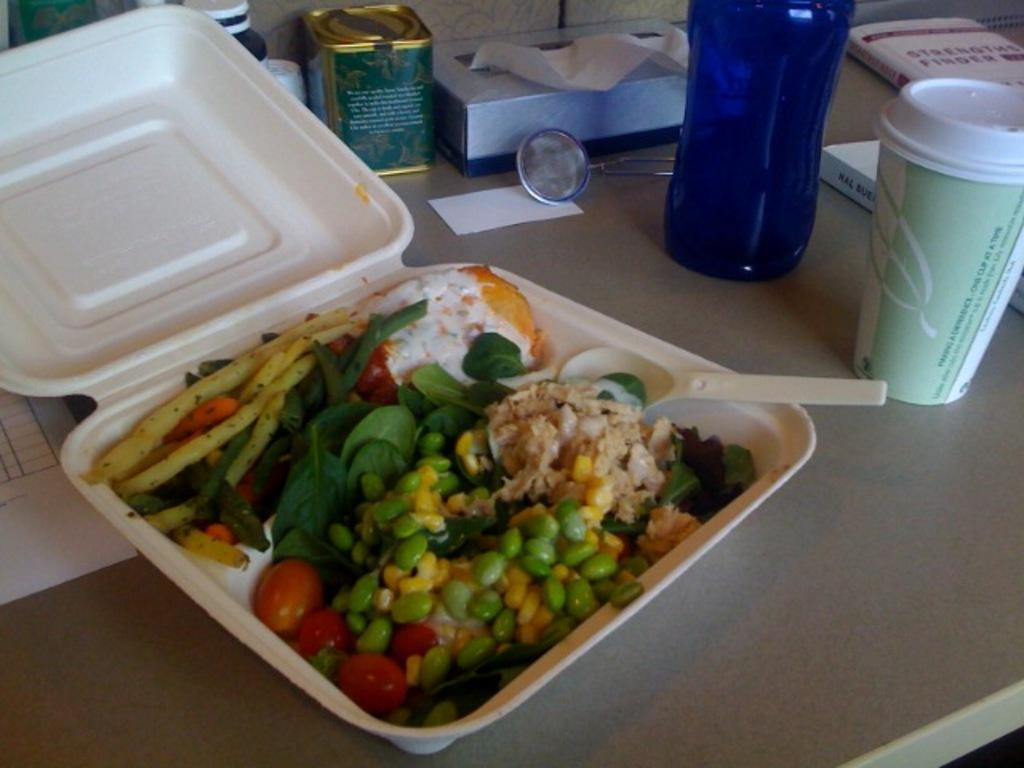What type of edible item can be seen in the image? There is an edible item in the image, but the specific type is not mentioned in the facts. What utensil is present in the image? There is a spoon in the image. How is the edible item and spoon contained in the image? The edible item and spoon are placed in a box. Where is the box located in the image? The box is on a table. What other items can be seen in the image? There is a bottle and two books in the image, as well as other objects. What is the texture of the floor in the image? There is no mention of a floor in the image, so the texture cannot be determined. 